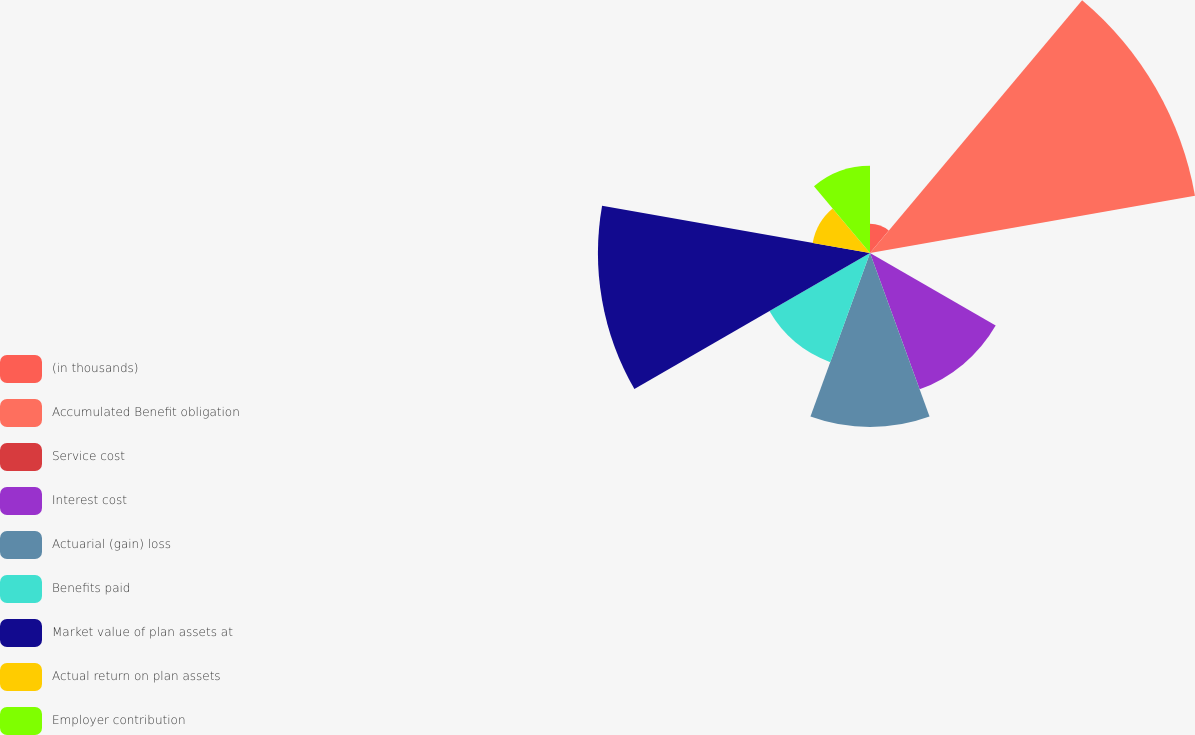Convert chart. <chart><loc_0><loc_0><loc_500><loc_500><pie_chart><fcel>(in thousands)<fcel>Accumulated Benefit obligation<fcel>Service cost<fcel>Interest cost<fcel>Actuarial (gain) loss<fcel>Benefits paid<fcel>Market value of plan assets at<fcel>Actual return on plan assets<fcel>Employer contribution<nl><fcel>2.41%<fcel>27.22%<fcel>0.02%<fcel>11.97%<fcel>14.36%<fcel>9.58%<fcel>22.44%<fcel>4.8%<fcel>7.19%<nl></chart> 